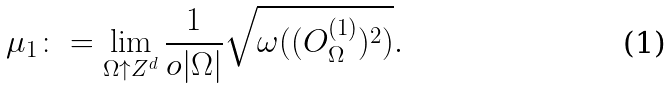Convert formula to latex. <formula><loc_0><loc_0><loc_500><loc_500>\mu _ { 1 } \colon = \lim _ { \Omega \uparrow { Z } ^ { d } } \frac { 1 } { o | \Omega | } \sqrt { \omega ( ( O ^ { ( 1 ) } _ { \Omega } ) ^ { 2 } ) } .</formula> 